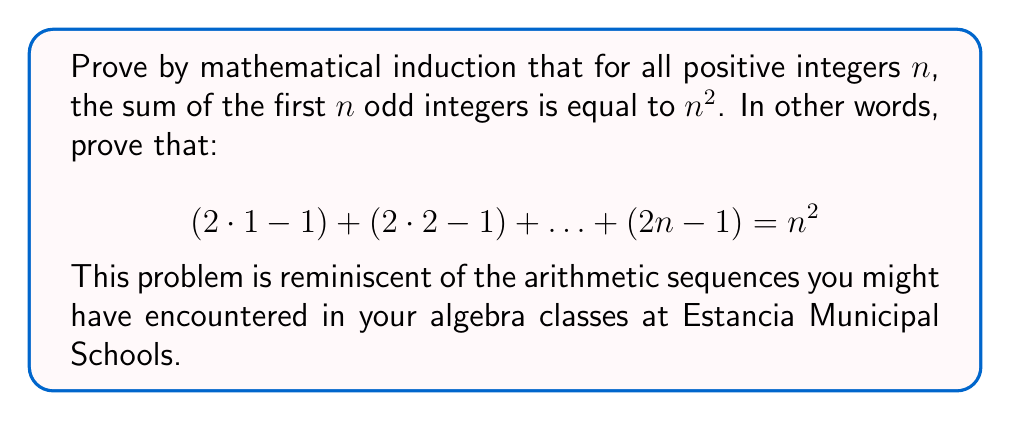Can you answer this question? Let's prove this statement using mathematical induction:

1) Base case: Let $n = 1$
   For $n = 1$, the left side of the equation is $(2 \cdot 1 - 1) = 1$
   The right side is $1^2 = 1$
   Thus, the statement holds for $n = 1$

2) Inductive hypothesis: Assume the statement is true for some positive integer $k$. That is:
   $$(2 \cdot 1 - 1) + (2 \cdot 2 - 1) + \ldots + (2k - 1) = k^2$$

3) Inductive step: We need to prove that the statement is true for $k+1$:
   $$(2 \cdot 1 - 1) + (2 \cdot 2 - 1) + \ldots + (2k - 1) + (2(k+1) - 1) = (k+1)^2$$

   Let's start with the left side:
   $$(2 \cdot 1 - 1) + (2 \cdot 2 - 1) + \ldots + (2k - 1) + (2(k+1) - 1)$$
   
   By our inductive hypothesis, we know that the sum of the first $k$ terms is $k^2$, so we can rewrite this as:
   $$k^2 + (2(k+1) - 1)$$
   
   Simplify the last term:
   $$k^2 + (2k + 2 - 1) = k^2 + (2k + 1)$$
   
   Now, let's expand $(k+1)^2$:
   $$(k+1)^2 = k^2 + 2k + 1$$
   
   We can see that $k^2 + (2k + 1) = k^2 + 2k + 1 = (k+1)^2$

Therefore, we have proven that if the statement is true for $k$, it is also true for $k+1$.

Since we have proven both the base case and the inductive step, by the principle of mathematical induction, the statement is true for all positive integers $n$.
Answer: The statement is proven true for all positive integers $n$. The sum of the first $n$ odd integers is equal to $n^2$. 